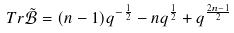Convert formula to latex. <formula><loc_0><loc_0><loc_500><loc_500>T r \tilde { \mathcal { B } } = ( n - 1 ) q ^ { - \frac { 1 } { 2 } } - n q ^ { \frac { 1 } { 2 } } + q ^ { \frac { 2 n - 1 } { 2 } }</formula> 